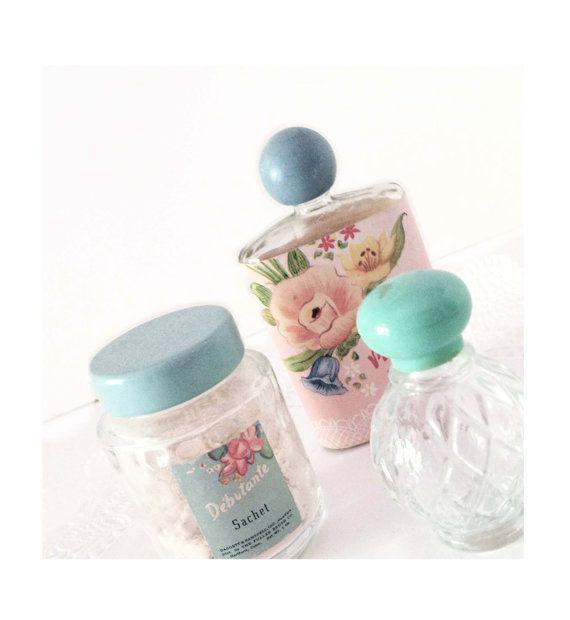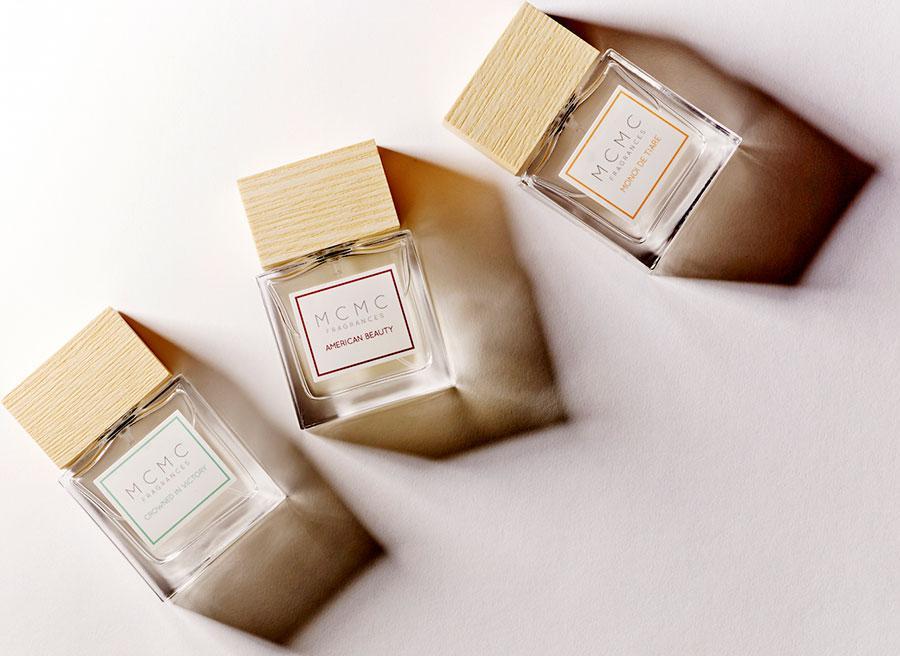The first image is the image on the left, the second image is the image on the right. For the images displayed, is the sentence "there is a perfume container with a chain and tassles" factually correct? Answer yes or no. No. The first image is the image on the left, the second image is the image on the right. For the images shown, is this caption "A golden bottle of perfume with a golden chain and black tassel is sitting next to a matching golden box." true? Answer yes or no. No. 